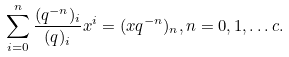Convert formula to latex. <formula><loc_0><loc_0><loc_500><loc_500>\sum _ { i = 0 } ^ { n } \frac { ( q ^ { - n } ) _ { i } } { ( q ) _ { i } } x ^ { i } = ( x q ^ { - n } ) _ { n } , n = 0 , 1 , \dots c .</formula> 